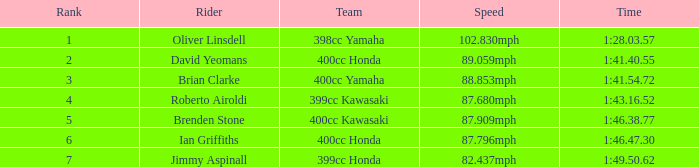55? 2.0. 